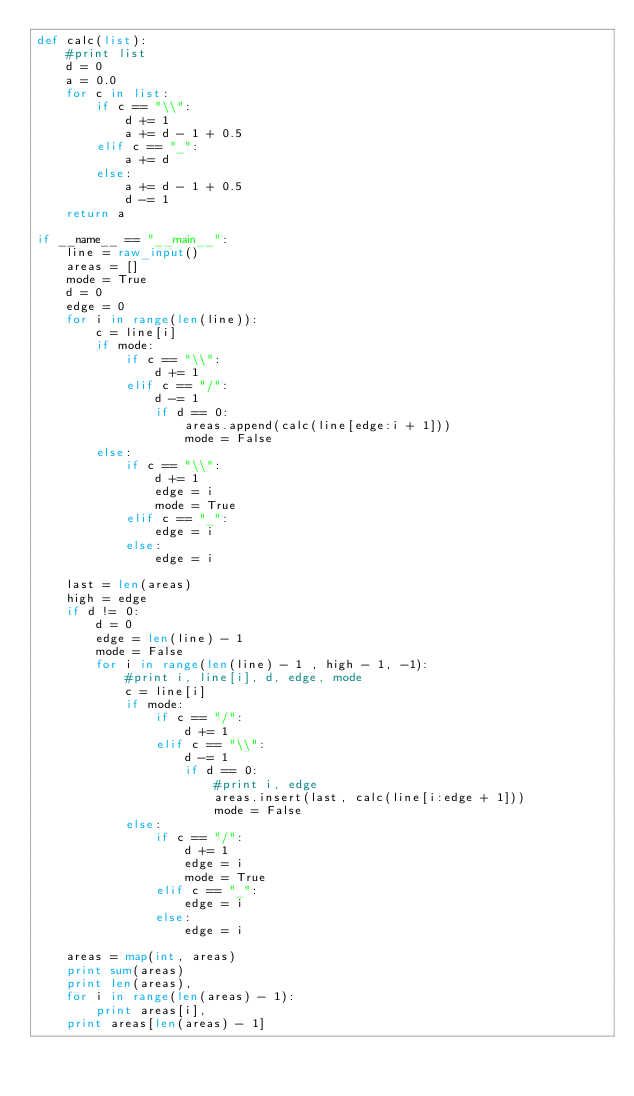<code> <loc_0><loc_0><loc_500><loc_500><_Python_>def calc(list):
    #print list
    d = 0
    a = 0.0
    for c in list:
        if c == "\\":
            d += 1
            a += d - 1 + 0.5
        elif c == "_":
            a += d
        else:
            a += d - 1 + 0.5
            d -= 1
    return a

if __name__ == "__main__":
    line = raw_input()
    areas = []
    mode = True
    d = 0
    edge = 0
    for i in range(len(line)):
        c = line[i]
        if mode:
            if c == "\\":
                d += 1
            elif c == "/":
                d -= 1
                if d == 0:
                    areas.append(calc(line[edge:i + 1]))
                    mode = False
        else:
            if c == "\\":
                d += 1
                edge = i
                mode = True
            elif c == "_":
                edge = i
            else:
                edge = i

    last = len(areas)
    high = edge
    if d != 0:
        d = 0
        edge = len(line) - 1
        mode = False
        for i in range(len(line) - 1 , high - 1, -1):
            #print i, line[i], d, edge, mode
            c = line[i]
            if mode:
                if c == "/":
                    d += 1
                elif c == "\\":
                    d -= 1
                    if d == 0:
                        #print i, edge
                        areas.insert(last, calc(line[i:edge + 1]))
                        mode = False
            else:
                if c == "/":
                    d += 1
                    edge = i
                    mode = True
                elif c == "_":
                    edge = i
                else:
                    edge = i

    areas = map(int, areas)
    print sum(areas)
    print len(areas),
    for i in range(len(areas) - 1):
        print areas[i],
    print areas[len(areas) - 1]</code> 